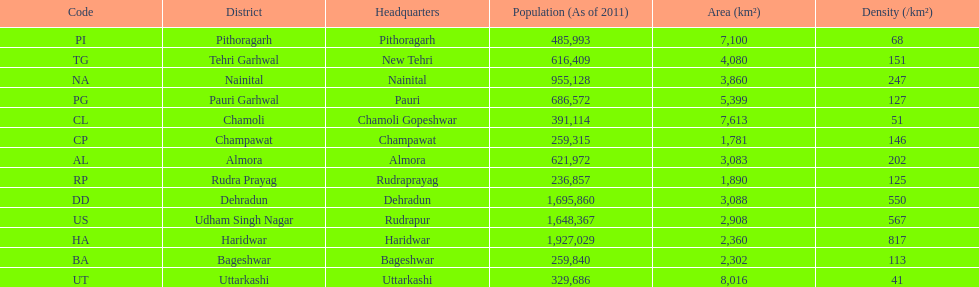Tell me the number of districts with an area over 5000. 4. 